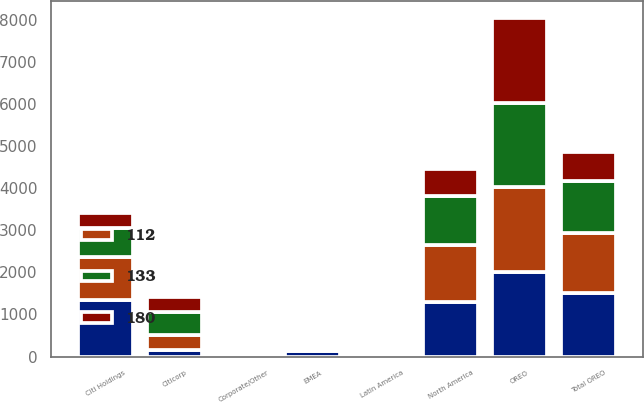Convert chart to OTSL. <chart><loc_0><loc_0><loc_500><loc_500><stacked_bar_chart><ecel><fcel>OREO<fcel>Citicorp<fcel>Citi Holdings<fcel>Corporate/Other<fcel>Total OREO<fcel>North America<fcel>EMEA<fcel>Latin America<nl><fcel>nan<fcel>2009<fcel>148<fcel>1341<fcel>11<fcel>1500<fcel>1294<fcel>121<fcel>45<nl><fcel>112<fcel>2008<fcel>371<fcel>1022<fcel>40<fcel>1433<fcel>1349<fcel>66<fcel>16<nl><fcel>133<fcel>2007<fcel>541<fcel>679<fcel>8<fcel>1228<fcel>1168<fcel>40<fcel>17<nl><fcel>180<fcel>2006<fcel>342<fcel>358<fcel>1<fcel>701<fcel>640<fcel>35<fcel>19<nl></chart> 